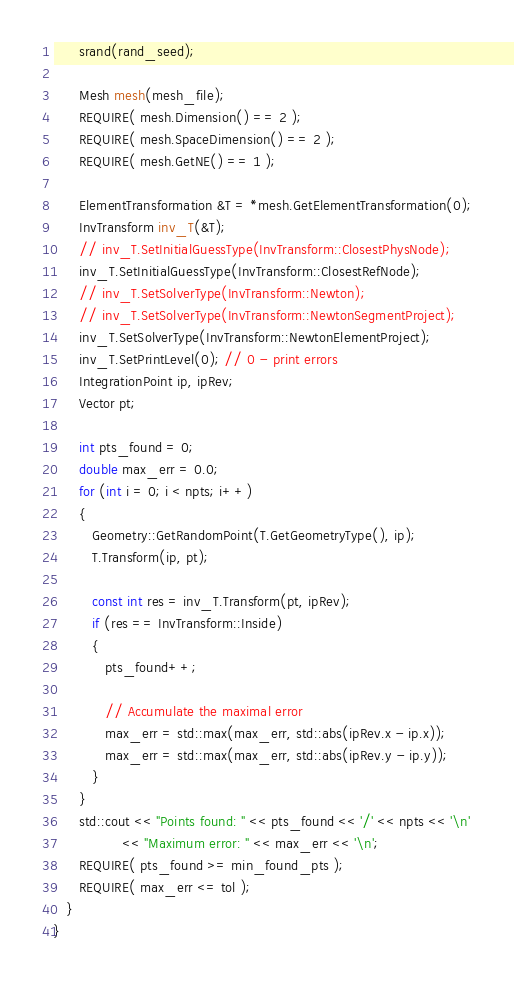<code> <loc_0><loc_0><loc_500><loc_500><_C++_>      srand(rand_seed);

      Mesh mesh(mesh_file);
      REQUIRE( mesh.Dimension() == 2 );
      REQUIRE( mesh.SpaceDimension() == 2 );
      REQUIRE( mesh.GetNE() == 1 );

      ElementTransformation &T = *mesh.GetElementTransformation(0);
      InvTransform inv_T(&T);
      // inv_T.SetInitialGuessType(InvTransform::ClosestPhysNode);
      inv_T.SetInitialGuessType(InvTransform::ClosestRefNode);
      // inv_T.SetSolverType(InvTransform::Newton);
      // inv_T.SetSolverType(InvTransform::NewtonSegmentProject);
      inv_T.SetSolverType(InvTransform::NewtonElementProject);
      inv_T.SetPrintLevel(0); // 0 - print errors
      IntegrationPoint ip, ipRev;
      Vector pt;

      int pts_found = 0;
      double max_err = 0.0;
      for (int i = 0; i < npts; i++)
      {
         Geometry::GetRandomPoint(T.GetGeometryType(), ip);
         T.Transform(ip, pt);

         const int res = inv_T.Transform(pt, ipRev);
         if (res == InvTransform::Inside)
         {
            pts_found++;

            // Accumulate the maximal error
            max_err = std::max(max_err, std::abs(ipRev.x - ip.x));
            max_err = std::max(max_err, std::abs(ipRev.y - ip.y));
         }
      }
      std::cout << "Points found: " << pts_found << '/' << npts << '\n'
                << "Maximum error: " << max_err << '\n';
      REQUIRE( pts_found >= min_found_pts );
      REQUIRE( max_err <= tol );
   }
}
</code> 